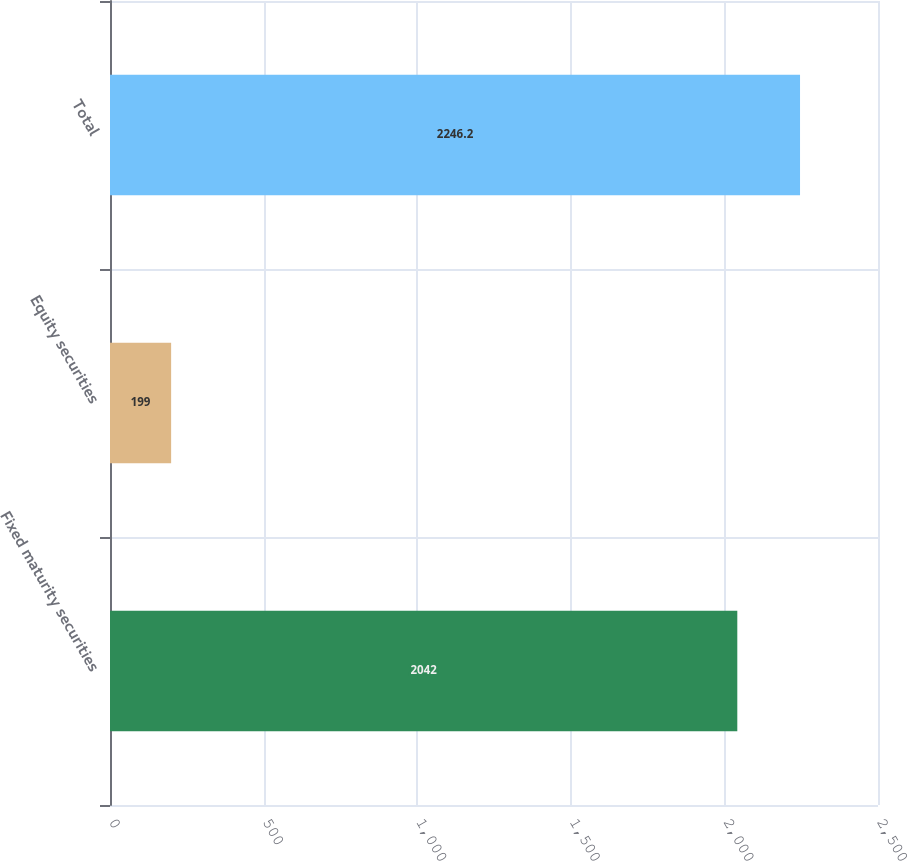Convert chart. <chart><loc_0><loc_0><loc_500><loc_500><bar_chart><fcel>Fixed maturity securities<fcel>Equity securities<fcel>Total<nl><fcel>2042<fcel>199<fcel>2246.2<nl></chart> 